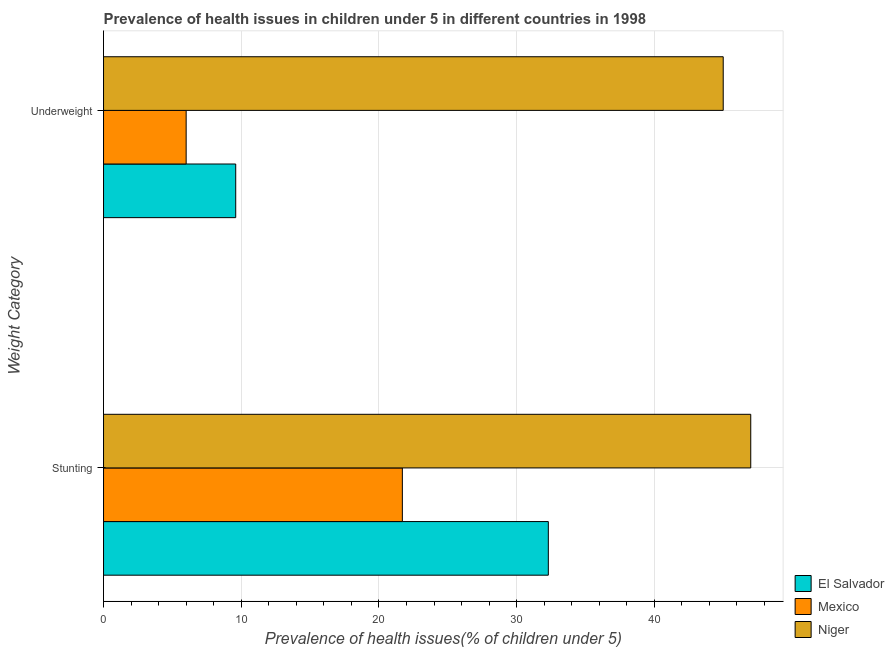How many different coloured bars are there?
Offer a very short reply. 3. How many groups of bars are there?
Your answer should be compact. 2. Are the number of bars per tick equal to the number of legend labels?
Ensure brevity in your answer.  Yes. What is the label of the 1st group of bars from the top?
Your answer should be compact. Underweight. What is the percentage of stunted children in Mexico?
Offer a terse response. 21.7. Across all countries, what is the maximum percentage of stunted children?
Provide a short and direct response. 47. In which country was the percentage of underweight children maximum?
Your answer should be very brief. Niger. In which country was the percentage of stunted children minimum?
Provide a short and direct response. Mexico. What is the total percentage of stunted children in the graph?
Keep it short and to the point. 101. What is the difference between the percentage of underweight children in Mexico and that in El Salvador?
Provide a succinct answer. -3.6. What is the average percentage of underweight children per country?
Offer a very short reply. 20.2. What is the ratio of the percentage of stunted children in Niger to that in Mexico?
Ensure brevity in your answer.  2.17. Is the percentage of stunted children in Niger less than that in Mexico?
Provide a short and direct response. No. In how many countries, is the percentage of stunted children greater than the average percentage of stunted children taken over all countries?
Provide a short and direct response. 1. What does the 2nd bar from the top in Underweight represents?
Ensure brevity in your answer.  Mexico. What does the 3rd bar from the bottom in Underweight represents?
Provide a short and direct response. Niger. How many bars are there?
Provide a succinct answer. 6. How many countries are there in the graph?
Your answer should be compact. 3. What is the difference between two consecutive major ticks on the X-axis?
Offer a terse response. 10. Are the values on the major ticks of X-axis written in scientific E-notation?
Your response must be concise. No. Does the graph contain any zero values?
Provide a succinct answer. No. Does the graph contain grids?
Provide a succinct answer. Yes. Where does the legend appear in the graph?
Provide a succinct answer. Bottom right. What is the title of the graph?
Make the answer very short. Prevalence of health issues in children under 5 in different countries in 1998. Does "Canada" appear as one of the legend labels in the graph?
Your answer should be very brief. No. What is the label or title of the X-axis?
Offer a very short reply. Prevalence of health issues(% of children under 5). What is the label or title of the Y-axis?
Offer a very short reply. Weight Category. What is the Prevalence of health issues(% of children under 5) of El Salvador in Stunting?
Offer a very short reply. 32.3. What is the Prevalence of health issues(% of children under 5) of Mexico in Stunting?
Make the answer very short. 21.7. What is the Prevalence of health issues(% of children under 5) in El Salvador in Underweight?
Ensure brevity in your answer.  9.6. Across all Weight Category, what is the maximum Prevalence of health issues(% of children under 5) of El Salvador?
Make the answer very short. 32.3. Across all Weight Category, what is the maximum Prevalence of health issues(% of children under 5) in Mexico?
Your answer should be very brief. 21.7. Across all Weight Category, what is the minimum Prevalence of health issues(% of children under 5) of El Salvador?
Keep it short and to the point. 9.6. Across all Weight Category, what is the minimum Prevalence of health issues(% of children under 5) of Mexico?
Provide a succinct answer. 6. Across all Weight Category, what is the minimum Prevalence of health issues(% of children under 5) in Niger?
Keep it short and to the point. 45. What is the total Prevalence of health issues(% of children under 5) of El Salvador in the graph?
Make the answer very short. 41.9. What is the total Prevalence of health issues(% of children under 5) of Mexico in the graph?
Give a very brief answer. 27.7. What is the total Prevalence of health issues(% of children under 5) of Niger in the graph?
Provide a short and direct response. 92. What is the difference between the Prevalence of health issues(% of children under 5) in El Salvador in Stunting and that in Underweight?
Provide a short and direct response. 22.7. What is the difference between the Prevalence of health issues(% of children under 5) of Mexico in Stunting and that in Underweight?
Your answer should be very brief. 15.7. What is the difference between the Prevalence of health issues(% of children under 5) in El Salvador in Stunting and the Prevalence of health issues(% of children under 5) in Mexico in Underweight?
Make the answer very short. 26.3. What is the difference between the Prevalence of health issues(% of children under 5) of Mexico in Stunting and the Prevalence of health issues(% of children under 5) of Niger in Underweight?
Provide a succinct answer. -23.3. What is the average Prevalence of health issues(% of children under 5) of El Salvador per Weight Category?
Make the answer very short. 20.95. What is the average Prevalence of health issues(% of children under 5) in Mexico per Weight Category?
Ensure brevity in your answer.  13.85. What is the average Prevalence of health issues(% of children under 5) of Niger per Weight Category?
Provide a short and direct response. 46. What is the difference between the Prevalence of health issues(% of children under 5) of El Salvador and Prevalence of health issues(% of children under 5) of Mexico in Stunting?
Ensure brevity in your answer.  10.6. What is the difference between the Prevalence of health issues(% of children under 5) in El Salvador and Prevalence of health issues(% of children under 5) in Niger in Stunting?
Provide a succinct answer. -14.7. What is the difference between the Prevalence of health issues(% of children under 5) of Mexico and Prevalence of health issues(% of children under 5) of Niger in Stunting?
Make the answer very short. -25.3. What is the difference between the Prevalence of health issues(% of children under 5) of El Salvador and Prevalence of health issues(% of children under 5) of Mexico in Underweight?
Ensure brevity in your answer.  3.6. What is the difference between the Prevalence of health issues(% of children under 5) of El Salvador and Prevalence of health issues(% of children under 5) of Niger in Underweight?
Give a very brief answer. -35.4. What is the difference between the Prevalence of health issues(% of children under 5) in Mexico and Prevalence of health issues(% of children under 5) in Niger in Underweight?
Offer a very short reply. -39. What is the ratio of the Prevalence of health issues(% of children under 5) of El Salvador in Stunting to that in Underweight?
Offer a terse response. 3.36. What is the ratio of the Prevalence of health issues(% of children under 5) in Mexico in Stunting to that in Underweight?
Keep it short and to the point. 3.62. What is the ratio of the Prevalence of health issues(% of children under 5) in Niger in Stunting to that in Underweight?
Ensure brevity in your answer.  1.04. What is the difference between the highest and the second highest Prevalence of health issues(% of children under 5) of El Salvador?
Make the answer very short. 22.7. What is the difference between the highest and the second highest Prevalence of health issues(% of children under 5) in Mexico?
Offer a terse response. 15.7. What is the difference between the highest and the second highest Prevalence of health issues(% of children under 5) in Niger?
Your answer should be very brief. 2. What is the difference between the highest and the lowest Prevalence of health issues(% of children under 5) in El Salvador?
Your answer should be compact. 22.7. What is the difference between the highest and the lowest Prevalence of health issues(% of children under 5) of Mexico?
Make the answer very short. 15.7. What is the difference between the highest and the lowest Prevalence of health issues(% of children under 5) of Niger?
Make the answer very short. 2. 